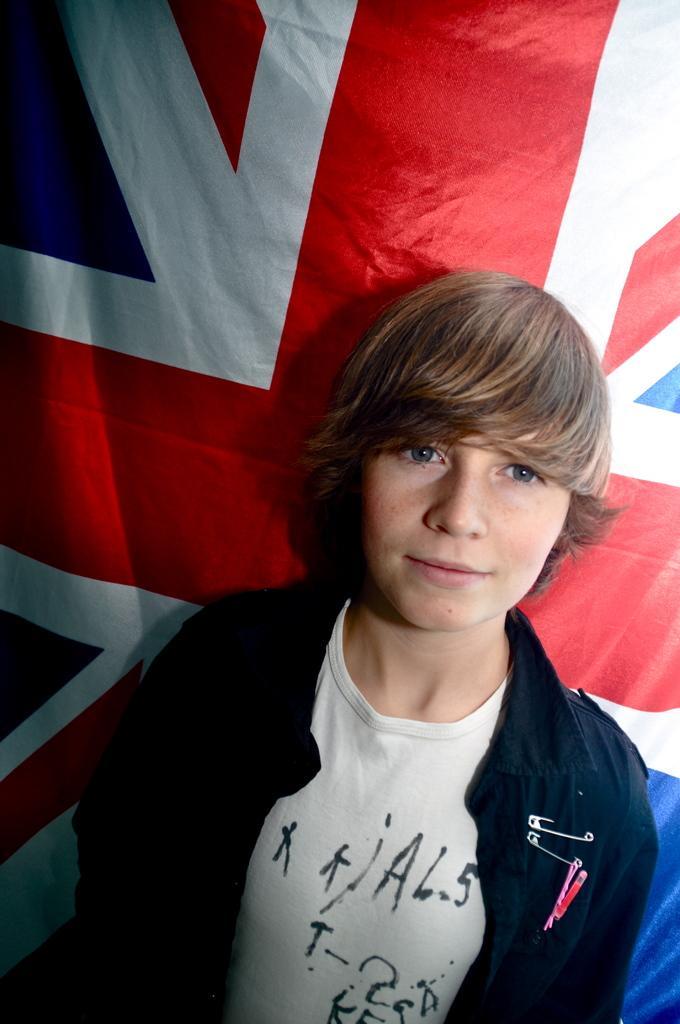In one or two sentences, can you explain what this image depicts? In this picture we can see a boy standing in front of a flag and looking at someone. 